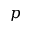<formula> <loc_0><loc_0><loc_500><loc_500>p</formula> 